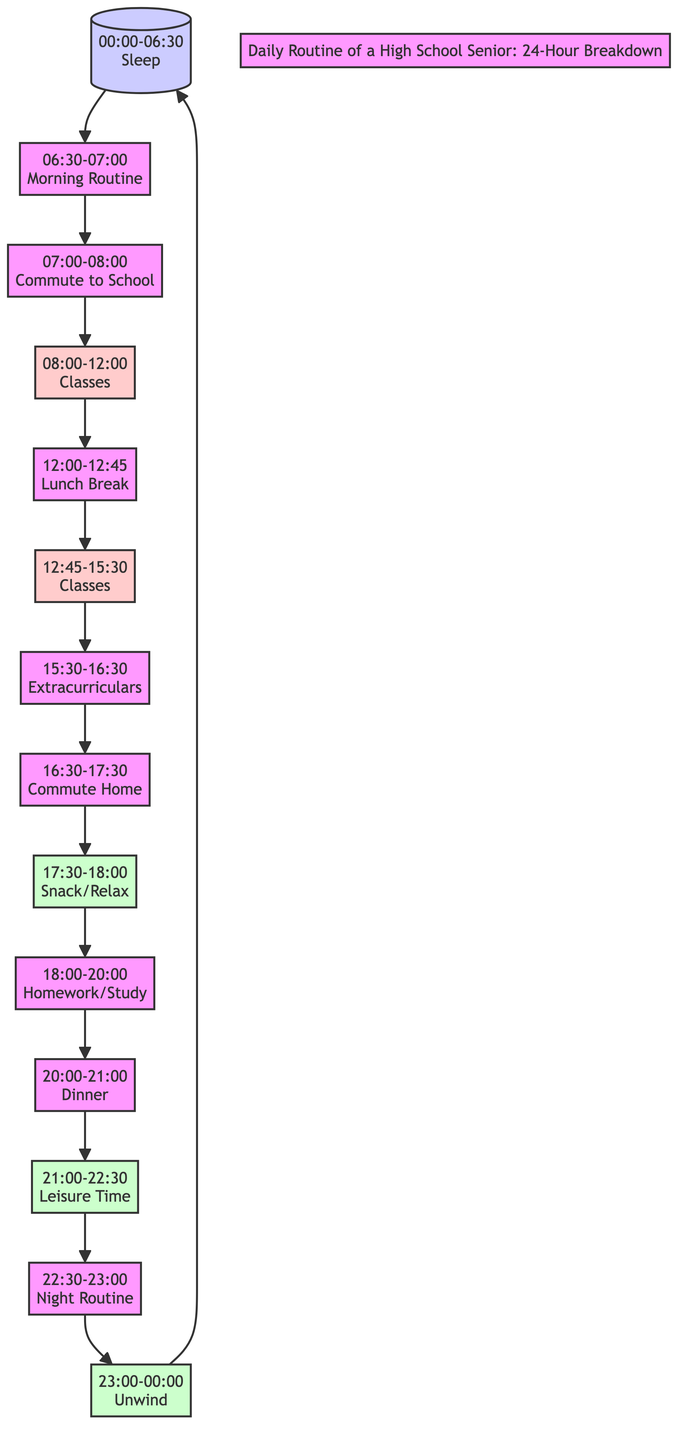What is the total number of activities listed in the diagram? The diagram contains a series of activities outlined in nodes. Counting each node, from sleep to unwind, we see there are 14 distinct activities.
Answer: 14 What time does the "Snack/Relax" activity take place? The "Snack/Relax" activity is represented by the node with the label "17:30-18:00." By locating this specific node in the diagram, we can identify its corresponding time.
Answer: 17:30-18:00 How long is the Homework/Study period? The node labeled "Homework/Study" indicates a time duration of 2 hours, from 18:00 to 20:00. To find this, I calculate the difference in start and end times within that specific node.
Answer: 2 hours What is the next activity after "Classes"? After the first "Classes" node (08:00-12:00), the subsequent activity is indicated as "Lunch Break." This can be confirmed by looking at the flow from the "Classes" node to the next.
Answer: Lunch Break Which activity occurs last in the daily routine before sleep? The final labeled activity preceding sleep is "Unwind," indicated as occurring from "23:00-00:00." By following the flowchart, we see that this activity is positioned just before the sleep node.
Answer: Unwind Identify the total duration of school-related activities in hours. The school-related blocks are “Classes” (08:00-12:00 and 12:45-15:30). The first spans 4 hours and the second spans 2 hours. Adding these, we get a total of 6 hours.
Answer: 6 hours What is the leisure time duration in total? The leisure time is represented by three labeled nodes: "Snack/Relax" (30 minutes), "Leisure Time" (1.5 hours), and "Unwind" (1 hour). Adding these durations gives a total of 3 hours.
Answer: 3 hours How much time is allocated for extracurricular activities? The diagram specifies an hour dedicated to "Extracurriculars," represented by a distinct node. This can be easily identified by the label duration shown in that node.
Answer: 1 hour What activity follows "Commuting Home"? The next activity after "Commuting Home" is labeled "Snack/Relax," which can be established by tracing the progression from the "Commute Home" node to the subsequent node.
Answer: Snack/Relax 